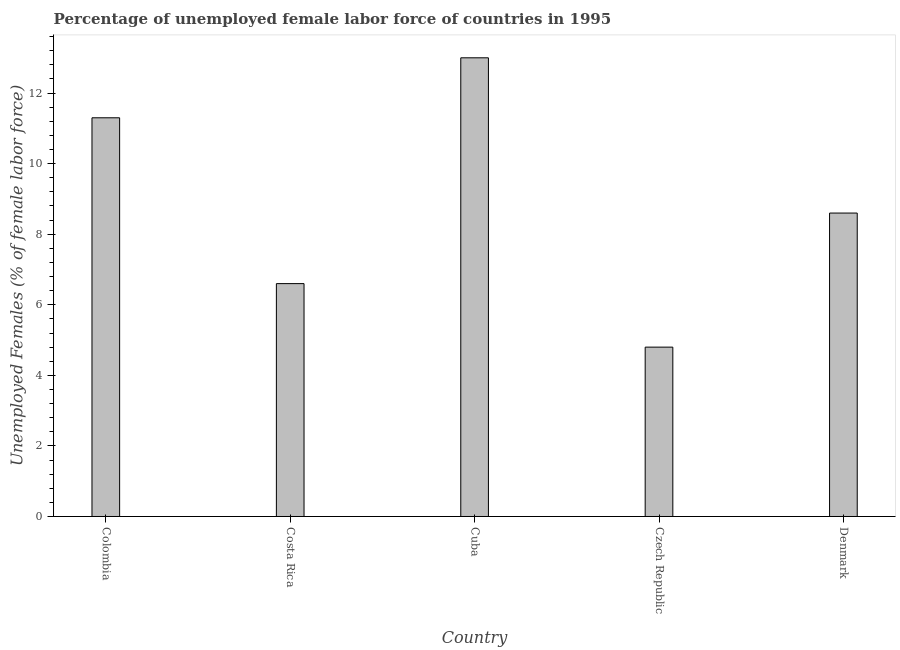Does the graph contain any zero values?
Keep it short and to the point. No. Does the graph contain grids?
Offer a terse response. No. What is the title of the graph?
Your answer should be very brief. Percentage of unemployed female labor force of countries in 1995. What is the label or title of the Y-axis?
Provide a succinct answer. Unemployed Females (% of female labor force). What is the total unemployed female labour force in Cuba?
Your response must be concise. 13. Across all countries, what is the minimum total unemployed female labour force?
Provide a short and direct response. 4.8. In which country was the total unemployed female labour force maximum?
Provide a succinct answer. Cuba. In which country was the total unemployed female labour force minimum?
Offer a terse response. Czech Republic. What is the sum of the total unemployed female labour force?
Your answer should be very brief. 44.3. What is the average total unemployed female labour force per country?
Offer a very short reply. 8.86. What is the median total unemployed female labour force?
Ensure brevity in your answer.  8.6. What is the ratio of the total unemployed female labour force in Cuba to that in Czech Republic?
Make the answer very short. 2.71. Is the difference between the total unemployed female labour force in Costa Rica and Czech Republic greater than the difference between any two countries?
Offer a terse response. No. What is the difference between the highest and the second highest total unemployed female labour force?
Provide a short and direct response. 1.7. Is the sum of the total unemployed female labour force in Cuba and Denmark greater than the maximum total unemployed female labour force across all countries?
Give a very brief answer. Yes. In how many countries, is the total unemployed female labour force greater than the average total unemployed female labour force taken over all countries?
Offer a very short reply. 2. How many countries are there in the graph?
Your answer should be very brief. 5. What is the Unemployed Females (% of female labor force) in Colombia?
Offer a very short reply. 11.3. What is the Unemployed Females (% of female labor force) in Costa Rica?
Provide a short and direct response. 6.6. What is the Unemployed Females (% of female labor force) of Cuba?
Offer a terse response. 13. What is the Unemployed Females (% of female labor force) in Czech Republic?
Make the answer very short. 4.8. What is the Unemployed Females (% of female labor force) in Denmark?
Give a very brief answer. 8.6. What is the difference between the Unemployed Females (% of female labor force) in Colombia and Cuba?
Offer a terse response. -1.7. What is the difference between the Unemployed Females (% of female labor force) in Colombia and Czech Republic?
Provide a short and direct response. 6.5. What is the difference between the Unemployed Females (% of female labor force) in Colombia and Denmark?
Your answer should be compact. 2.7. What is the difference between the Unemployed Females (% of female labor force) in Costa Rica and Cuba?
Your answer should be very brief. -6.4. What is the difference between the Unemployed Females (% of female labor force) in Costa Rica and Denmark?
Offer a terse response. -2. What is the difference between the Unemployed Females (% of female labor force) in Cuba and Czech Republic?
Your answer should be very brief. 8.2. What is the ratio of the Unemployed Females (% of female labor force) in Colombia to that in Costa Rica?
Your answer should be compact. 1.71. What is the ratio of the Unemployed Females (% of female labor force) in Colombia to that in Cuba?
Your answer should be compact. 0.87. What is the ratio of the Unemployed Females (% of female labor force) in Colombia to that in Czech Republic?
Your answer should be compact. 2.35. What is the ratio of the Unemployed Females (% of female labor force) in Colombia to that in Denmark?
Your response must be concise. 1.31. What is the ratio of the Unemployed Females (% of female labor force) in Costa Rica to that in Cuba?
Offer a very short reply. 0.51. What is the ratio of the Unemployed Females (% of female labor force) in Costa Rica to that in Czech Republic?
Provide a succinct answer. 1.38. What is the ratio of the Unemployed Females (% of female labor force) in Costa Rica to that in Denmark?
Offer a terse response. 0.77. What is the ratio of the Unemployed Females (% of female labor force) in Cuba to that in Czech Republic?
Provide a short and direct response. 2.71. What is the ratio of the Unemployed Females (% of female labor force) in Cuba to that in Denmark?
Give a very brief answer. 1.51. What is the ratio of the Unemployed Females (% of female labor force) in Czech Republic to that in Denmark?
Your response must be concise. 0.56. 